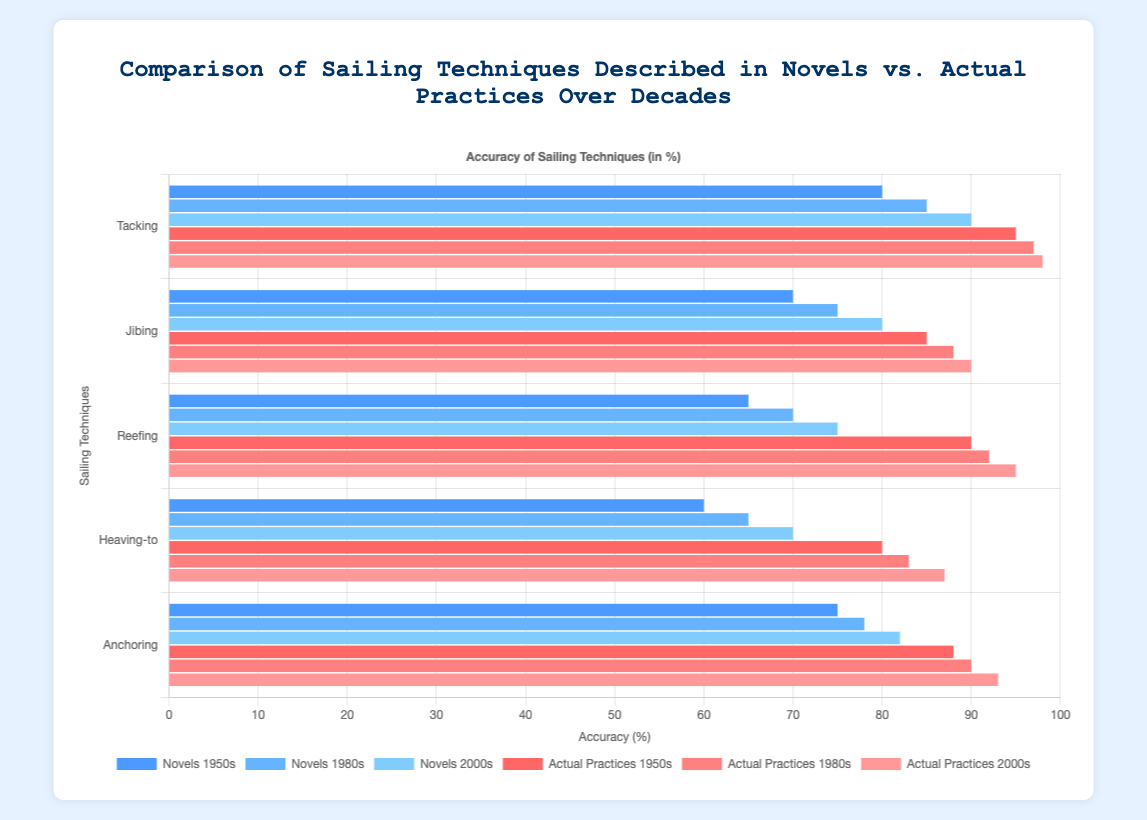How has the accuracy of the "Tacking" technique in novels changed from the 1950s to the 2000s? In the 1950s, the accuracy was 80%. In the 1980s, it increased to 85%, and in the 2000s, it reached 90%. The change in accuracy from the 1950s to the 2000s is 90 - 80 = 10%.
Answer: 10% Which sailing technique shows the largest discrepancy between novels and actual practices in the 2000s? For "Tacking," the discrepancy is 98 - 90 = 8%. For "Jibing," it is 90 - 80 = 10%. For "Reefing," it is 95 - 75 = 20%. For "Heaving-to," it is 87 - 70 = 17%. For "Anchoring," it is 93 - 82 = 11%. The largest discrepancy is with "Reefing" at 20%.
Answer: Reefing Which visual attribute (color) represents the "Actual Practices 1980s"? The dataset for "Actual Practices 1980s" is colored light red in the chart.
Answer: Light red By how much did the accuracy of "Jibing" in novels lag behind actual practices in the 1980s? In the 1980s, novels had an accuracy of 75% for "Jibing," while actual practices were at 88%. The lag is 88 - 75 = 13%.
Answer: 13% What is the average accuracy of "Reefing" in novels over the three decades? The accuracies for "Reefing" in novels are 65% (1950s), 70% (1980s), and 75% (2000s). The average is (65 + 70 + 75) / 3 = 70%.
Answer: 70% Which decade has the smallest difference between novel and actual practice accuracy for "Heaving-to"? In the 1950s, the difference is 80 - 60 = 20%. In the 1980s, it is 83 - 65 = 18%. In the 2000s, it is 87 - 70 = 17%. The smallest difference is in the 2000s at 17%.
Answer: 2000s How does the accuracy of "Anchoring" in the 1950s compare between novels and actual practices? In the 1950s, the accuracy for "Anchoring" in novels was 75%, while in actual practices it was 88%. The difference is 88 - 75 = 13%.
Answer: 13% Between the 1950s and 1980s, which technique in novels saw the greatest improvement in accuracy? Comparing the techniques: "Tacking" improved from 80% to 85% (5% improvement), "Jibing" from 70% to 75% (5%), "Reefing" from 65% to 70% (5%), "Heaving-to" from 60% to 65% (5%), "Anchoring" from 75% to 78% (3%). The improvements are all 5% except for "Anchoring," which is 3%, meaning no single technique saw greater improvement than others.
Answer: Tacking, Jibing, Reefing, Heaving-to (all tied) What was the overall trend in the accuracy of sailing techniques in novels over the decades? In novels, the accuracy for all techniques generally increased from the 1950s to the 2000s.
Answer: Increased 